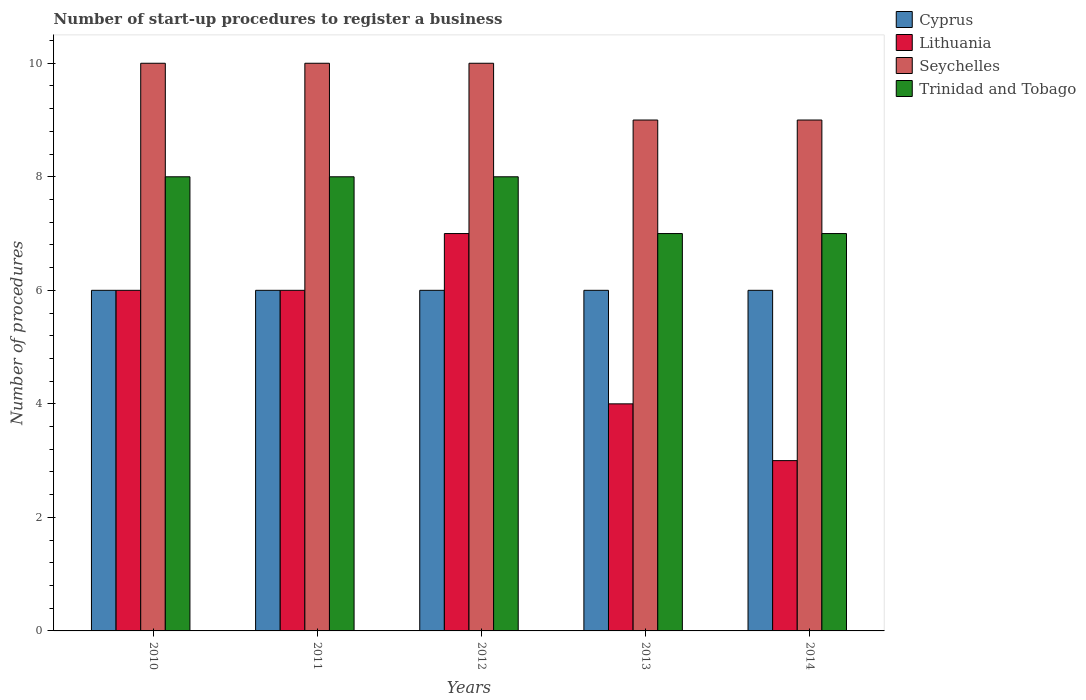How many groups of bars are there?
Ensure brevity in your answer.  5. How many bars are there on the 5th tick from the left?
Your answer should be compact. 4. How many bars are there on the 5th tick from the right?
Give a very brief answer. 4. What is the label of the 5th group of bars from the left?
Your response must be concise. 2014. Across all years, what is the maximum number of procedures required to register a business in Seychelles?
Offer a very short reply. 10. Across all years, what is the minimum number of procedures required to register a business in Seychelles?
Your answer should be compact. 9. In which year was the number of procedures required to register a business in Seychelles maximum?
Your answer should be compact. 2010. What is the difference between the number of procedures required to register a business in Trinidad and Tobago in 2012 and that in 2013?
Provide a succinct answer. 1. What is the difference between the number of procedures required to register a business in Trinidad and Tobago in 2014 and the number of procedures required to register a business in Lithuania in 2013?
Ensure brevity in your answer.  3. What is the average number of procedures required to register a business in Trinidad and Tobago per year?
Your response must be concise. 7.6. What is the ratio of the number of procedures required to register a business in Lithuania in 2010 to that in 2013?
Your answer should be very brief. 1.5. What is the difference between the highest and the second highest number of procedures required to register a business in Seychelles?
Ensure brevity in your answer.  0. What is the difference between the highest and the lowest number of procedures required to register a business in Seychelles?
Your answer should be very brief. 1. What does the 1st bar from the left in 2011 represents?
Your answer should be compact. Cyprus. What does the 3rd bar from the right in 2011 represents?
Provide a succinct answer. Lithuania. How many years are there in the graph?
Your answer should be very brief. 5. What is the difference between two consecutive major ticks on the Y-axis?
Offer a very short reply. 2. Are the values on the major ticks of Y-axis written in scientific E-notation?
Offer a terse response. No. Where does the legend appear in the graph?
Your response must be concise. Top right. How many legend labels are there?
Provide a succinct answer. 4. What is the title of the graph?
Offer a very short reply. Number of start-up procedures to register a business. What is the label or title of the Y-axis?
Your response must be concise. Number of procedures. What is the Number of procedures in Cyprus in 2010?
Offer a terse response. 6. What is the Number of procedures of Seychelles in 2010?
Your response must be concise. 10. What is the Number of procedures in Lithuania in 2011?
Your response must be concise. 6. What is the Number of procedures of Seychelles in 2011?
Provide a succinct answer. 10. What is the Number of procedures of Trinidad and Tobago in 2011?
Offer a terse response. 8. What is the Number of procedures in Cyprus in 2012?
Keep it short and to the point. 6. What is the Number of procedures in Lithuania in 2012?
Provide a succinct answer. 7. What is the Number of procedures of Seychelles in 2012?
Keep it short and to the point. 10. What is the Number of procedures in Lithuania in 2013?
Offer a terse response. 4. What is the Number of procedures of Seychelles in 2013?
Keep it short and to the point. 9. What is the Number of procedures in Lithuania in 2014?
Keep it short and to the point. 3. What is the Number of procedures in Trinidad and Tobago in 2014?
Provide a succinct answer. 7. Across all years, what is the maximum Number of procedures of Cyprus?
Offer a very short reply. 6. Across all years, what is the maximum Number of procedures of Lithuania?
Your response must be concise. 7. Across all years, what is the minimum Number of procedures in Cyprus?
Provide a short and direct response. 6. What is the total Number of procedures in Seychelles in the graph?
Offer a very short reply. 48. What is the total Number of procedures of Trinidad and Tobago in the graph?
Ensure brevity in your answer.  38. What is the difference between the Number of procedures of Cyprus in 2010 and that in 2011?
Give a very brief answer. 0. What is the difference between the Number of procedures of Trinidad and Tobago in 2010 and that in 2011?
Provide a succinct answer. 0. What is the difference between the Number of procedures in Seychelles in 2010 and that in 2012?
Offer a very short reply. 0. What is the difference between the Number of procedures in Cyprus in 2010 and that in 2013?
Offer a very short reply. 0. What is the difference between the Number of procedures of Trinidad and Tobago in 2010 and that in 2013?
Make the answer very short. 1. What is the difference between the Number of procedures of Cyprus in 2010 and that in 2014?
Offer a terse response. 0. What is the difference between the Number of procedures of Lithuania in 2010 and that in 2014?
Make the answer very short. 3. What is the difference between the Number of procedures in Trinidad and Tobago in 2011 and that in 2012?
Your response must be concise. 0. What is the difference between the Number of procedures of Seychelles in 2011 and that in 2013?
Make the answer very short. 1. What is the difference between the Number of procedures of Trinidad and Tobago in 2011 and that in 2014?
Your answer should be very brief. 1. What is the difference between the Number of procedures in Cyprus in 2012 and that in 2013?
Ensure brevity in your answer.  0. What is the difference between the Number of procedures in Lithuania in 2012 and that in 2013?
Give a very brief answer. 3. What is the difference between the Number of procedures in Seychelles in 2012 and that in 2014?
Make the answer very short. 1. What is the difference between the Number of procedures of Trinidad and Tobago in 2013 and that in 2014?
Provide a short and direct response. 0. What is the difference between the Number of procedures in Cyprus in 2010 and the Number of procedures in Lithuania in 2011?
Your answer should be very brief. 0. What is the difference between the Number of procedures in Cyprus in 2010 and the Number of procedures in Seychelles in 2011?
Ensure brevity in your answer.  -4. What is the difference between the Number of procedures of Cyprus in 2010 and the Number of procedures of Trinidad and Tobago in 2011?
Offer a very short reply. -2. What is the difference between the Number of procedures in Lithuania in 2010 and the Number of procedures in Trinidad and Tobago in 2011?
Provide a succinct answer. -2. What is the difference between the Number of procedures in Seychelles in 2010 and the Number of procedures in Trinidad and Tobago in 2011?
Your response must be concise. 2. What is the difference between the Number of procedures of Cyprus in 2010 and the Number of procedures of Seychelles in 2012?
Your answer should be compact. -4. What is the difference between the Number of procedures of Lithuania in 2010 and the Number of procedures of Seychelles in 2012?
Make the answer very short. -4. What is the difference between the Number of procedures in Lithuania in 2010 and the Number of procedures in Trinidad and Tobago in 2012?
Your answer should be very brief. -2. What is the difference between the Number of procedures of Seychelles in 2010 and the Number of procedures of Trinidad and Tobago in 2012?
Provide a short and direct response. 2. What is the difference between the Number of procedures in Cyprus in 2010 and the Number of procedures in Lithuania in 2013?
Make the answer very short. 2. What is the difference between the Number of procedures in Seychelles in 2010 and the Number of procedures in Trinidad and Tobago in 2013?
Your answer should be very brief. 3. What is the difference between the Number of procedures of Cyprus in 2010 and the Number of procedures of Trinidad and Tobago in 2014?
Offer a very short reply. -1. What is the difference between the Number of procedures of Lithuania in 2010 and the Number of procedures of Seychelles in 2014?
Ensure brevity in your answer.  -3. What is the difference between the Number of procedures of Seychelles in 2010 and the Number of procedures of Trinidad and Tobago in 2014?
Your answer should be very brief. 3. What is the difference between the Number of procedures in Cyprus in 2011 and the Number of procedures in Lithuania in 2012?
Offer a terse response. -1. What is the difference between the Number of procedures in Cyprus in 2011 and the Number of procedures in Trinidad and Tobago in 2012?
Ensure brevity in your answer.  -2. What is the difference between the Number of procedures in Lithuania in 2011 and the Number of procedures in Seychelles in 2012?
Your response must be concise. -4. What is the difference between the Number of procedures of Lithuania in 2011 and the Number of procedures of Trinidad and Tobago in 2012?
Provide a short and direct response. -2. What is the difference between the Number of procedures of Cyprus in 2011 and the Number of procedures of Lithuania in 2013?
Your response must be concise. 2. What is the difference between the Number of procedures in Cyprus in 2011 and the Number of procedures in Seychelles in 2013?
Your answer should be very brief. -3. What is the difference between the Number of procedures in Cyprus in 2011 and the Number of procedures in Trinidad and Tobago in 2013?
Provide a short and direct response. -1. What is the difference between the Number of procedures in Lithuania in 2011 and the Number of procedures in Seychelles in 2013?
Provide a short and direct response. -3. What is the difference between the Number of procedures of Cyprus in 2011 and the Number of procedures of Seychelles in 2014?
Offer a terse response. -3. What is the difference between the Number of procedures in Lithuania in 2011 and the Number of procedures in Seychelles in 2014?
Keep it short and to the point. -3. What is the difference between the Number of procedures in Lithuania in 2011 and the Number of procedures in Trinidad and Tobago in 2014?
Keep it short and to the point. -1. What is the difference between the Number of procedures in Cyprus in 2012 and the Number of procedures in Seychelles in 2013?
Provide a short and direct response. -3. What is the difference between the Number of procedures of Lithuania in 2012 and the Number of procedures of Trinidad and Tobago in 2013?
Offer a very short reply. 0. What is the difference between the Number of procedures in Seychelles in 2012 and the Number of procedures in Trinidad and Tobago in 2013?
Offer a very short reply. 3. What is the difference between the Number of procedures of Cyprus in 2012 and the Number of procedures of Trinidad and Tobago in 2014?
Provide a short and direct response. -1. What is the difference between the Number of procedures of Lithuania in 2012 and the Number of procedures of Seychelles in 2014?
Provide a short and direct response. -2. What is the difference between the Number of procedures of Cyprus in 2013 and the Number of procedures of Seychelles in 2014?
Make the answer very short. -3. What is the difference between the Number of procedures of Cyprus in 2013 and the Number of procedures of Trinidad and Tobago in 2014?
Your answer should be compact. -1. What is the difference between the Number of procedures of Lithuania in 2013 and the Number of procedures of Seychelles in 2014?
Make the answer very short. -5. What is the difference between the Number of procedures in Lithuania in 2013 and the Number of procedures in Trinidad and Tobago in 2014?
Provide a short and direct response. -3. What is the difference between the Number of procedures in Seychelles in 2013 and the Number of procedures in Trinidad and Tobago in 2014?
Your answer should be compact. 2. What is the average Number of procedures of Seychelles per year?
Your response must be concise. 9.6. In the year 2010, what is the difference between the Number of procedures of Cyprus and Number of procedures of Lithuania?
Offer a terse response. 0. In the year 2010, what is the difference between the Number of procedures of Cyprus and Number of procedures of Seychelles?
Offer a terse response. -4. In the year 2010, what is the difference between the Number of procedures of Cyprus and Number of procedures of Trinidad and Tobago?
Make the answer very short. -2. In the year 2010, what is the difference between the Number of procedures in Lithuania and Number of procedures in Trinidad and Tobago?
Offer a very short reply. -2. In the year 2010, what is the difference between the Number of procedures in Seychelles and Number of procedures in Trinidad and Tobago?
Give a very brief answer. 2. In the year 2011, what is the difference between the Number of procedures of Cyprus and Number of procedures of Lithuania?
Your response must be concise. 0. In the year 2012, what is the difference between the Number of procedures of Cyprus and Number of procedures of Lithuania?
Keep it short and to the point. -1. In the year 2012, what is the difference between the Number of procedures in Lithuania and Number of procedures in Seychelles?
Your answer should be compact. -3. In the year 2012, what is the difference between the Number of procedures of Lithuania and Number of procedures of Trinidad and Tobago?
Make the answer very short. -1. In the year 2012, what is the difference between the Number of procedures of Seychelles and Number of procedures of Trinidad and Tobago?
Provide a succinct answer. 2. In the year 2013, what is the difference between the Number of procedures of Cyprus and Number of procedures of Seychelles?
Keep it short and to the point. -3. In the year 2013, what is the difference between the Number of procedures in Lithuania and Number of procedures in Seychelles?
Make the answer very short. -5. In the year 2014, what is the difference between the Number of procedures in Cyprus and Number of procedures in Lithuania?
Offer a very short reply. 3. In the year 2014, what is the difference between the Number of procedures in Lithuania and Number of procedures in Seychelles?
Offer a very short reply. -6. In the year 2014, what is the difference between the Number of procedures of Seychelles and Number of procedures of Trinidad and Tobago?
Give a very brief answer. 2. What is the ratio of the Number of procedures in Cyprus in 2010 to that in 2011?
Give a very brief answer. 1. What is the ratio of the Number of procedures of Seychelles in 2010 to that in 2011?
Offer a very short reply. 1. What is the ratio of the Number of procedures of Cyprus in 2010 to that in 2013?
Offer a very short reply. 1. What is the ratio of the Number of procedures in Lithuania in 2010 to that in 2013?
Keep it short and to the point. 1.5. What is the ratio of the Number of procedures in Lithuania in 2010 to that in 2014?
Keep it short and to the point. 2. What is the ratio of the Number of procedures of Trinidad and Tobago in 2010 to that in 2014?
Keep it short and to the point. 1.14. What is the ratio of the Number of procedures in Lithuania in 2011 to that in 2012?
Give a very brief answer. 0.86. What is the ratio of the Number of procedures of Seychelles in 2011 to that in 2012?
Provide a short and direct response. 1. What is the ratio of the Number of procedures in Trinidad and Tobago in 2011 to that in 2012?
Keep it short and to the point. 1. What is the ratio of the Number of procedures in Seychelles in 2011 to that in 2013?
Offer a very short reply. 1.11. What is the ratio of the Number of procedures of Trinidad and Tobago in 2011 to that in 2013?
Provide a succinct answer. 1.14. What is the ratio of the Number of procedures in Cyprus in 2011 to that in 2014?
Provide a succinct answer. 1. What is the ratio of the Number of procedures of Seychelles in 2011 to that in 2014?
Ensure brevity in your answer.  1.11. What is the ratio of the Number of procedures of Trinidad and Tobago in 2011 to that in 2014?
Provide a short and direct response. 1.14. What is the ratio of the Number of procedures in Lithuania in 2012 to that in 2013?
Keep it short and to the point. 1.75. What is the ratio of the Number of procedures of Lithuania in 2012 to that in 2014?
Give a very brief answer. 2.33. What is the difference between the highest and the second highest Number of procedures in Cyprus?
Offer a terse response. 0. What is the difference between the highest and the second highest Number of procedures in Seychelles?
Your answer should be compact. 0. 